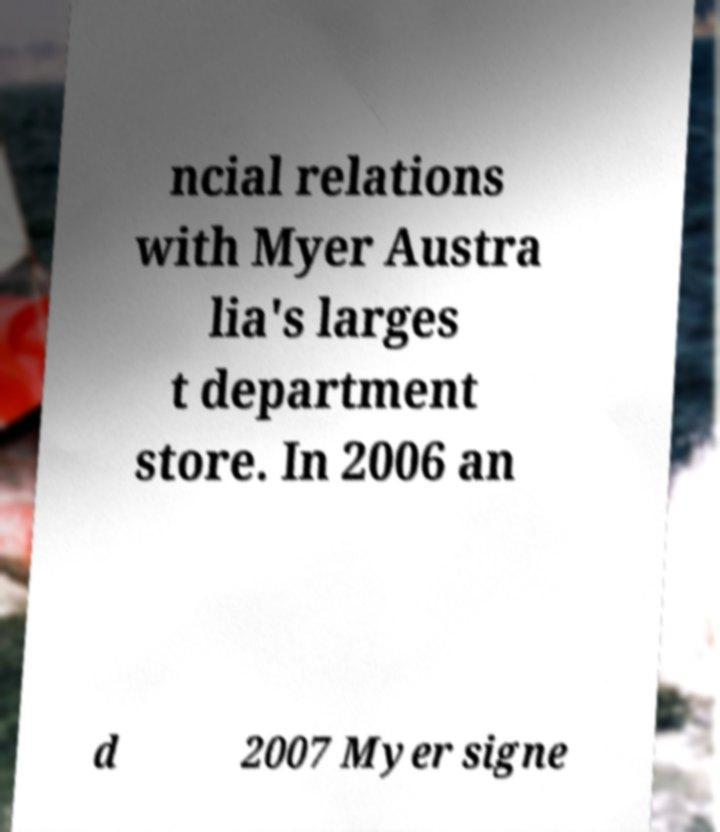Could you assist in decoding the text presented in this image and type it out clearly? ncial relations with Myer Austra lia's larges t department store. In 2006 an d 2007 Myer signe 